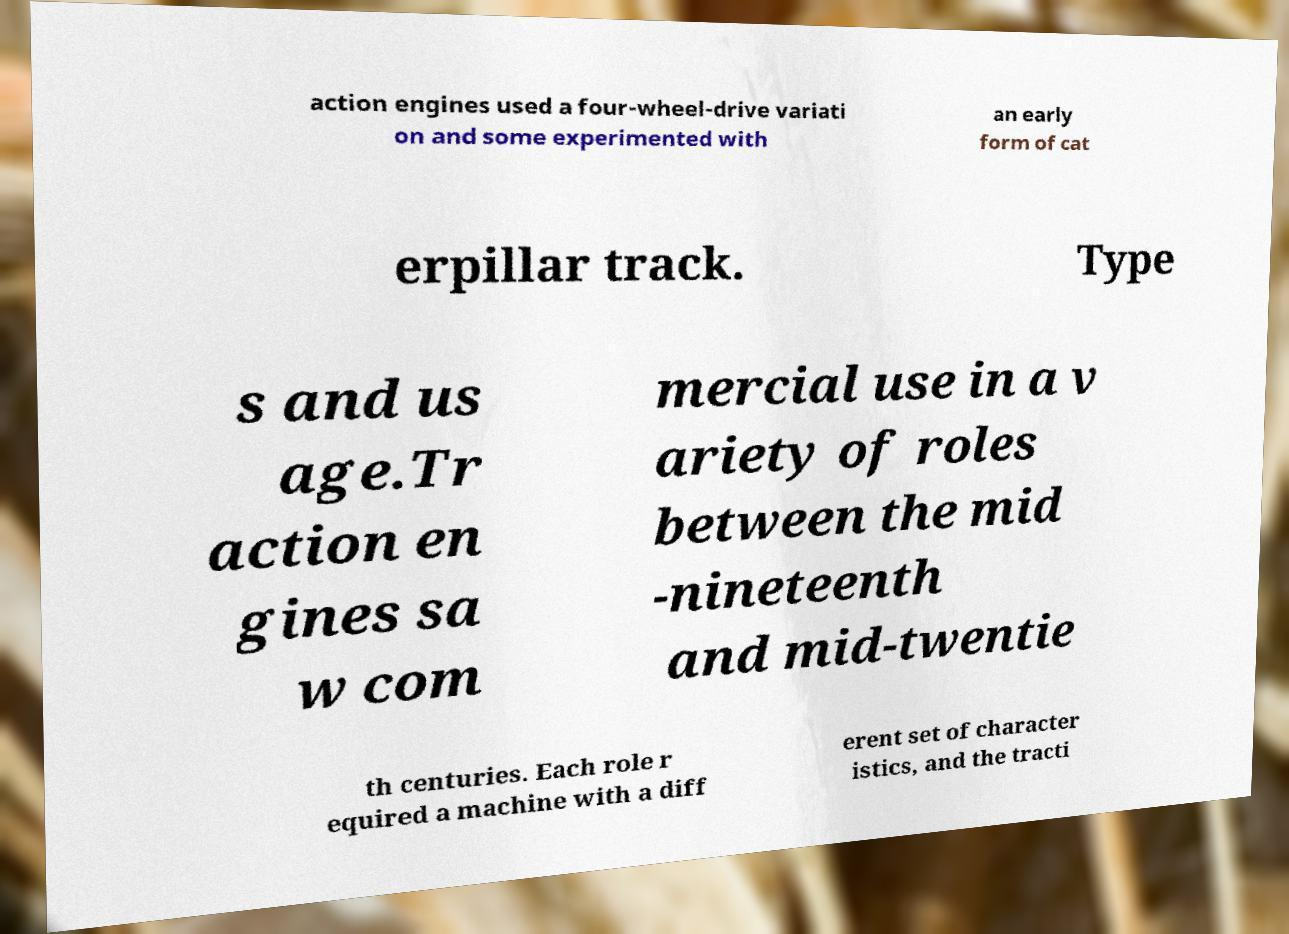Can you read and provide the text displayed in the image?This photo seems to have some interesting text. Can you extract and type it out for me? action engines used a four-wheel-drive variati on and some experimented with an early form of cat erpillar track. Type s and us age.Tr action en gines sa w com mercial use in a v ariety of roles between the mid -nineteenth and mid-twentie th centuries. Each role r equired a machine with a diff erent set of character istics, and the tracti 